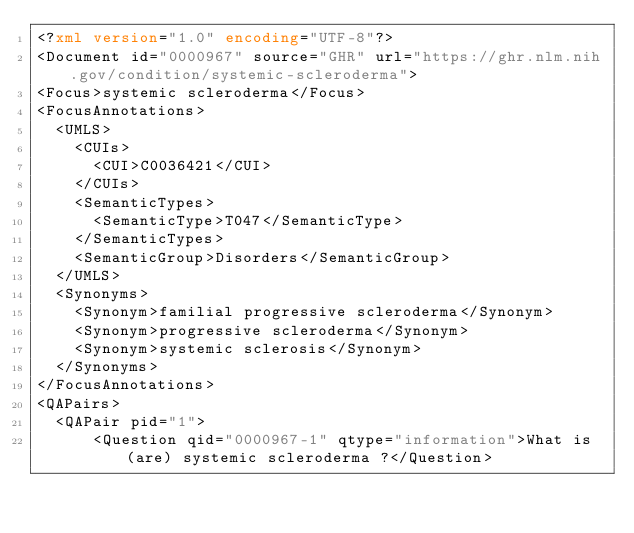<code> <loc_0><loc_0><loc_500><loc_500><_XML_><?xml version="1.0" encoding="UTF-8"?>
<Document id="0000967" source="GHR" url="https://ghr.nlm.nih.gov/condition/systemic-scleroderma">
<Focus>systemic scleroderma</Focus>
<FocusAnnotations>
	<UMLS>
		<CUIs>
			<CUI>C0036421</CUI>
		</CUIs>
		<SemanticTypes>
			<SemanticType>T047</SemanticType>
		</SemanticTypes>
		<SemanticGroup>Disorders</SemanticGroup>
	</UMLS>
	<Synonyms>
		<Synonym>familial progressive scleroderma</Synonym>
		<Synonym>progressive scleroderma</Synonym>
		<Synonym>systemic sclerosis</Synonym>
	</Synonyms>
</FocusAnnotations>
<QAPairs>
	<QAPair pid="1">
			<Question qid="0000967-1" qtype="information">What is (are) systemic scleroderma ?</Question></code> 